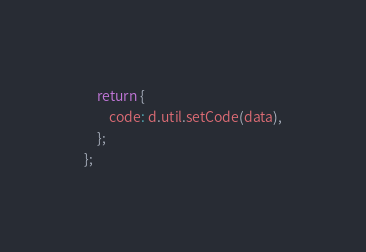Convert code to text. <code><loc_0><loc_0><loc_500><loc_500><_JavaScript_>    return {
        code: d.util.setCode(data),
    };
};
</code> 